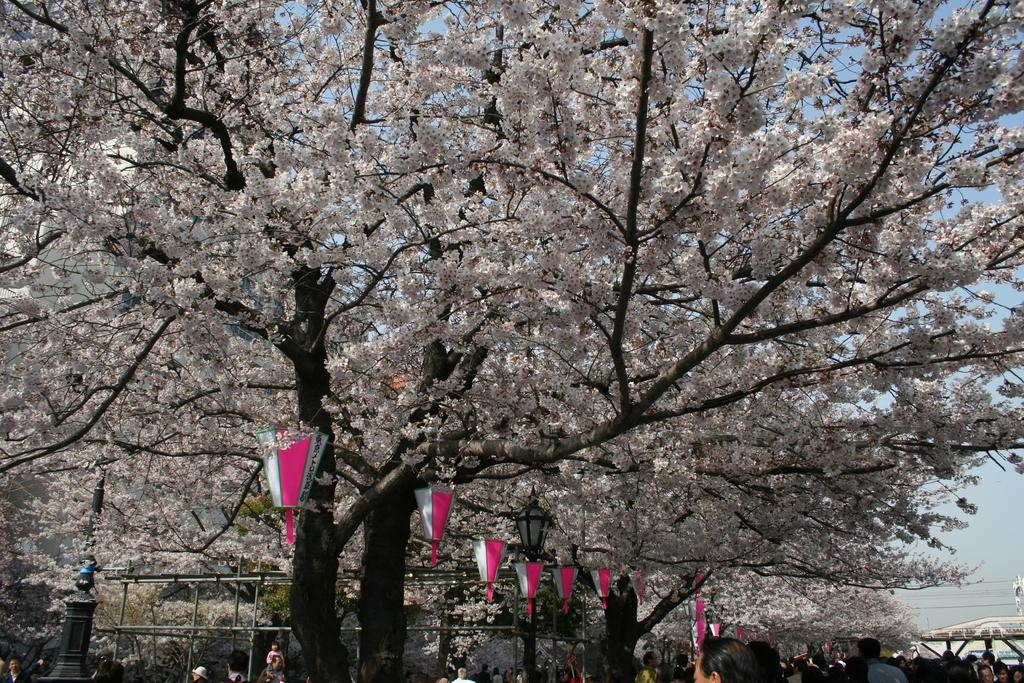What type of natural elements can be seen in the image? There are trees in the image. What else is present in the image besides trees? There are people and poles in the image. What can be seen in the sky in the image? The sky is visible in the image. What else is present in the image that might be related to infrastructure? There are wires in the image. What type of wool can be seen on the trees in the image? There is no wool present on the trees in the image. What color is the copper used for the wires in the image? The image does not provide information about the color or material of the wires. 